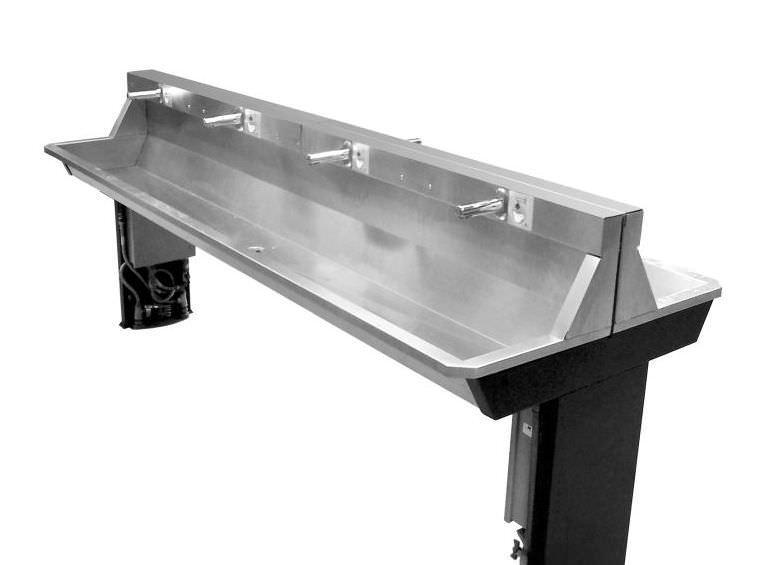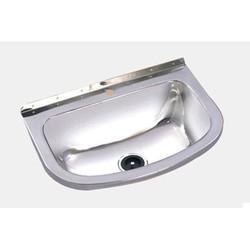The first image is the image on the left, the second image is the image on the right. For the images displayed, is the sentence "An image shows a long sink unit with at least three faucets." factually correct? Answer yes or no. Yes. The first image is the image on the left, the second image is the image on the right. Given the left and right images, does the statement "Each sink featured has only one bowl, and one faucet." hold true? Answer yes or no. No. 